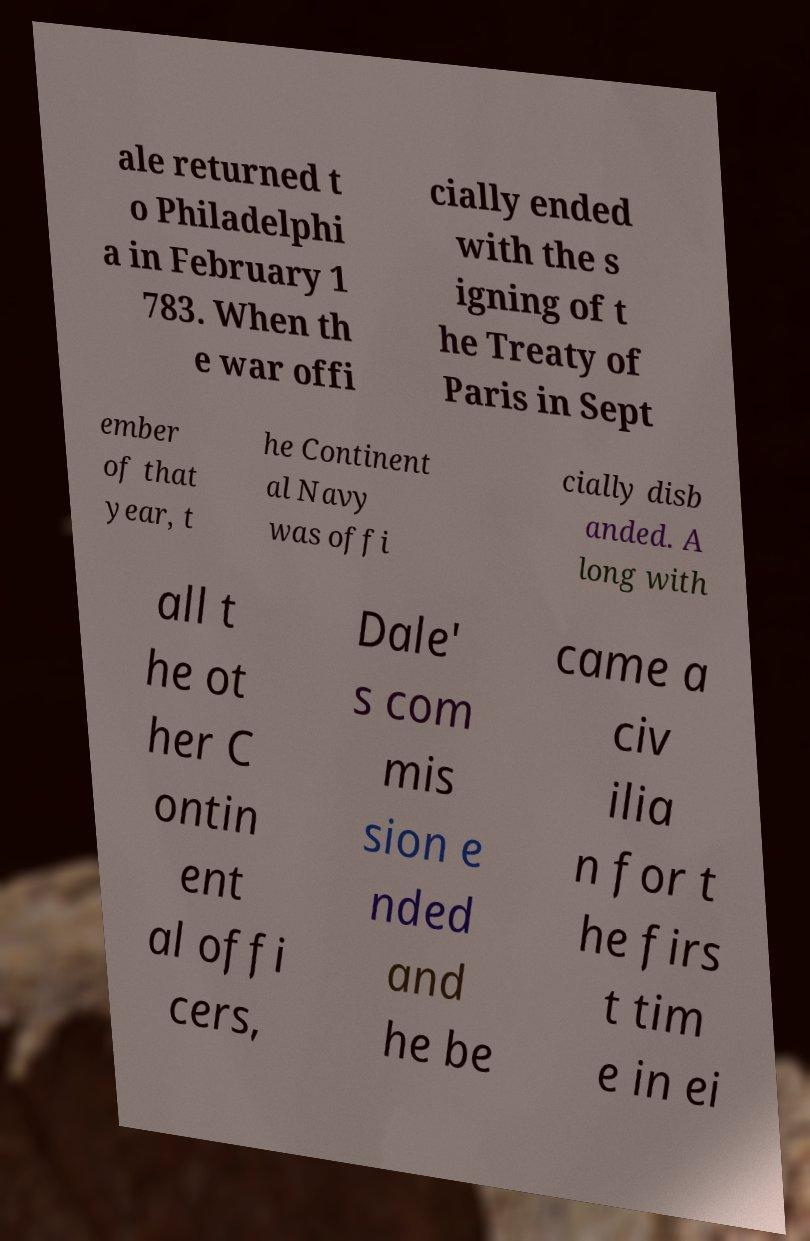Please identify and transcribe the text found in this image. ale returned t o Philadelphi a in February 1 783. When th e war offi cially ended with the s igning of t he Treaty of Paris in Sept ember of that year, t he Continent al Navy was offi cially disb anded. A long with all t he ot her C ontin ent al offi cers, Dale' s com mis sion e nded and he be came a civ ilia n for t he firs t tim e in ei 